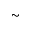<formula> <loc_0><loc_0><loc_500><loc_500>\sim</formula> 